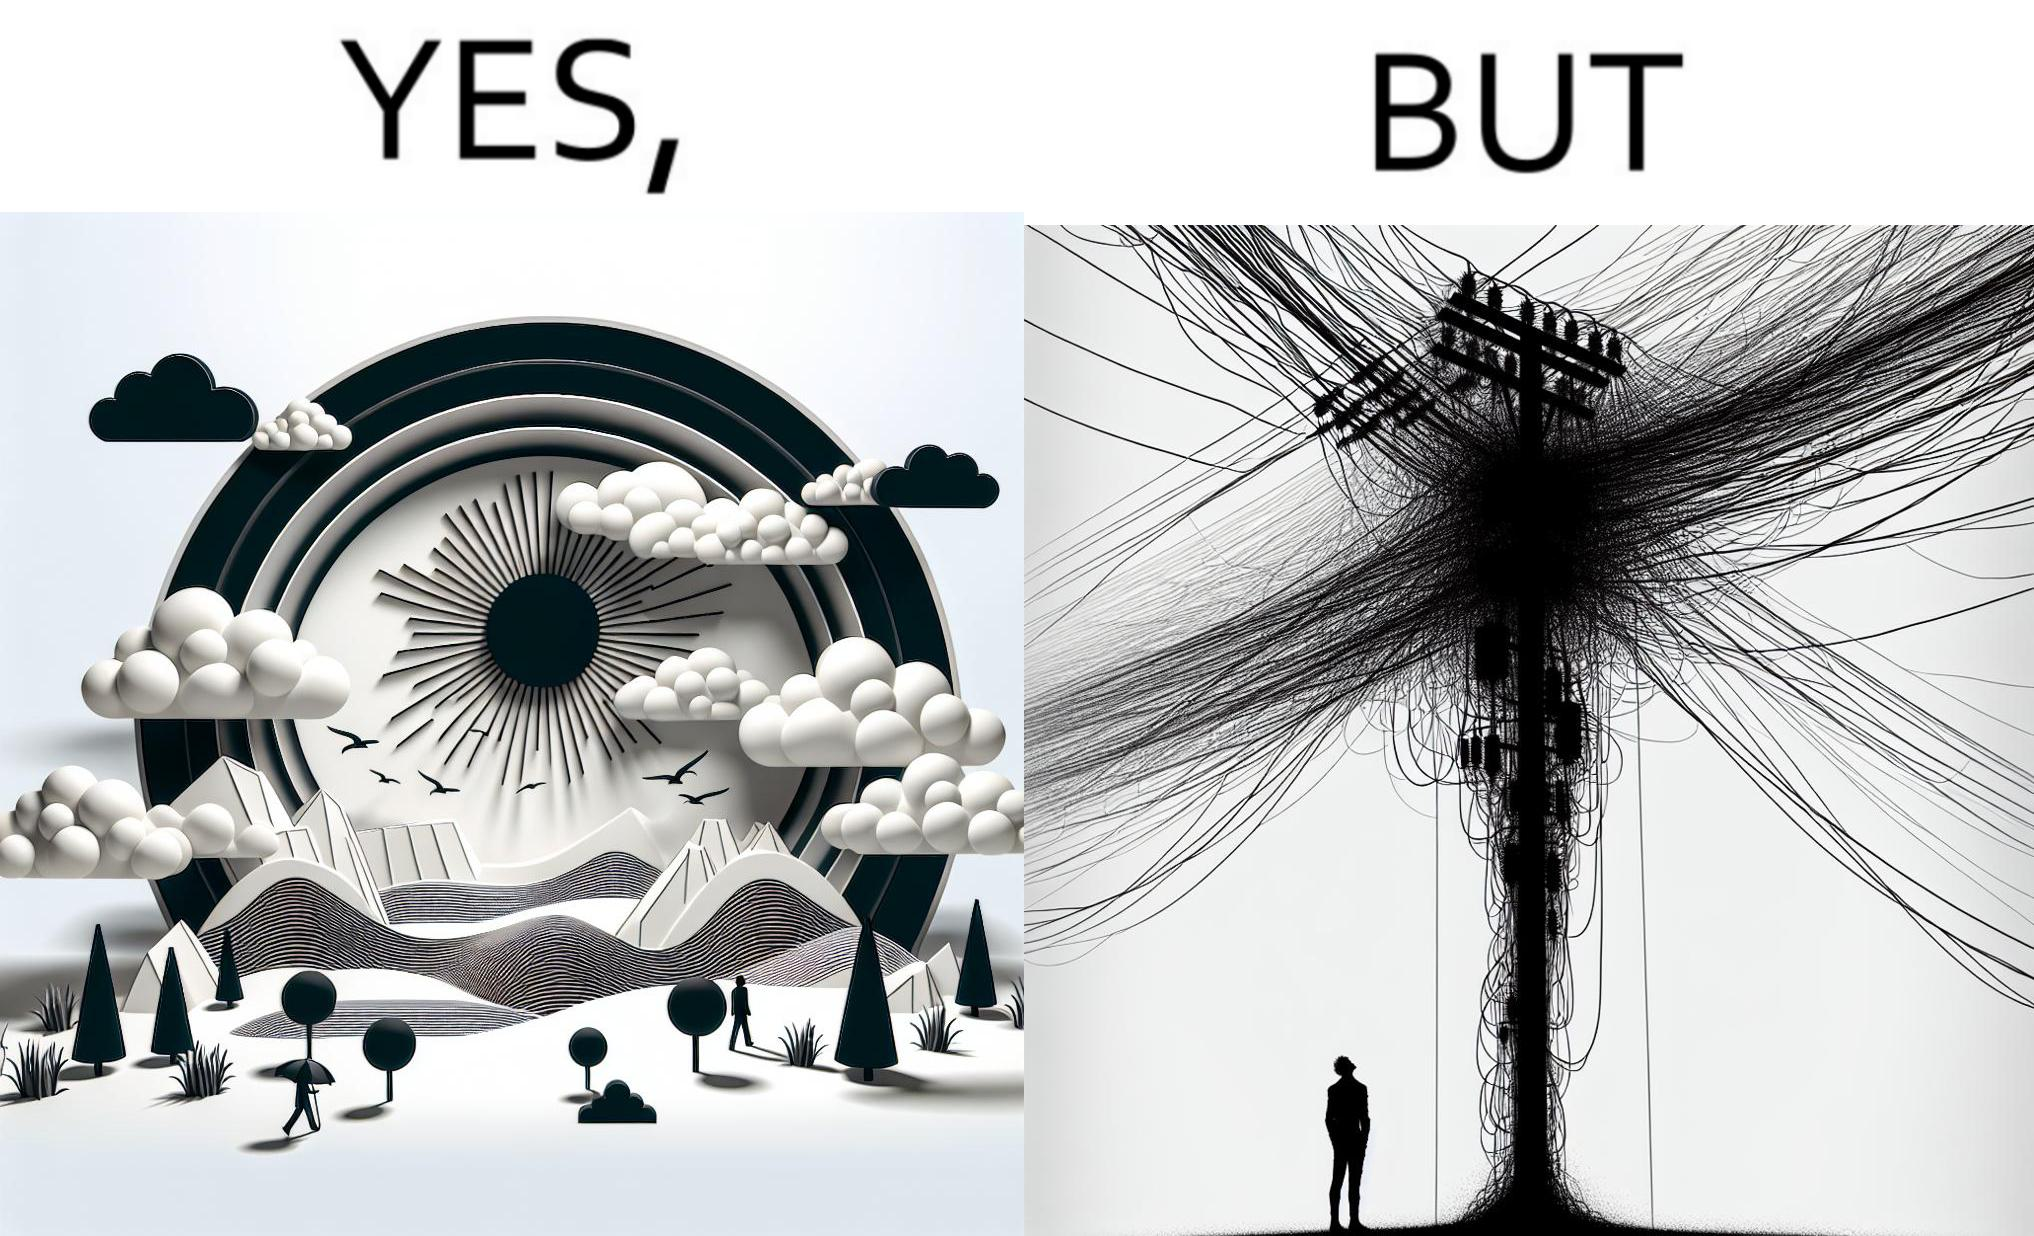Explain why this image is satirical. The image is ironic, because in the first image clear sky is visible but in the second image the same view is getting blocked due to the electricity pole 